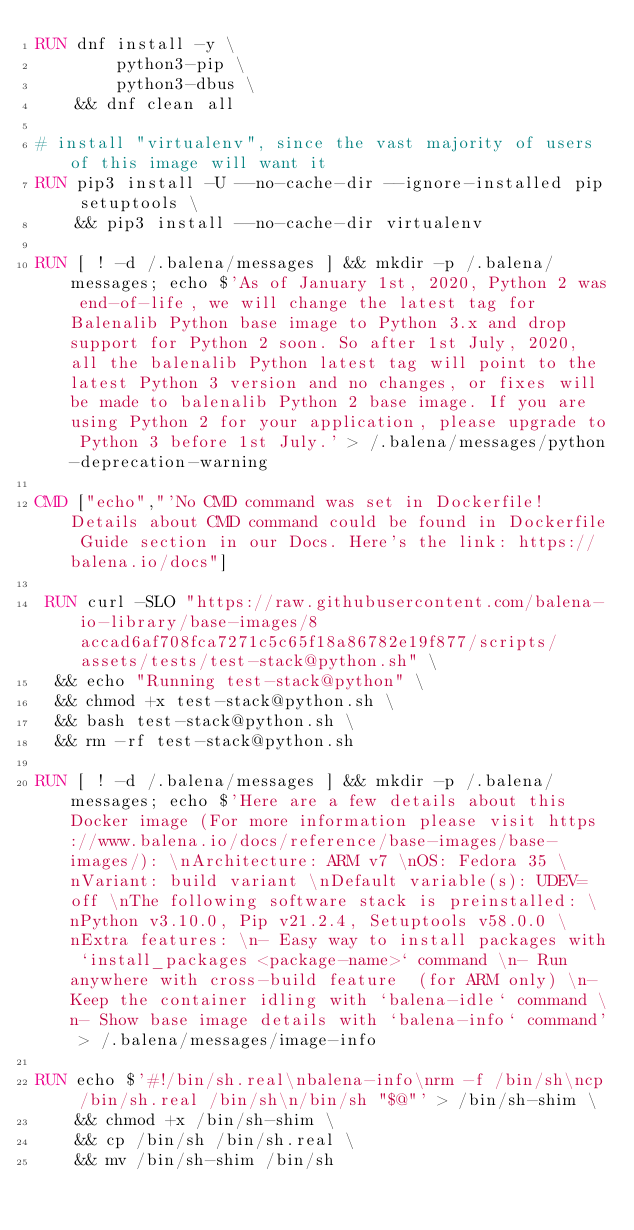Convert code to text. <code><loc_0><loc_0><loc_500><loc_500><_Dockerfile_>RUN dnf install -y \
		python3-pip \
		python3-dbus \
	&& dnf clean all

# install "virtualenv", since the vast majority of users of this image will want it
RUN pip3 install -U --no-cache-dir --ignore-installed pip setuptools \
	&& pip3 install --no-cache-dir virtualenv

RUN [ ! -d /.balena/messages ] && mkdir -p /.balena/messages; echo $'As of January 1st, 2020, Python 2 was end-of-life, we will change the latest tag for Balenalib Python base image to Python 3.x and drop support for Python 2 soon. So after 1st July, 2020, all the balenalib Python latest tag will point to the latest Python 3 version and no changes, or fixes will be made to balenalib Python 2 base image. If you are using Python 2 for your application, please upgrade to Python 3 before 1st July.' > /.balena/messages/python-deprecation-warning

CMD ["echo","'No CMD command was set in Dockerfile! Details about CMD command could be found in Dockerfile Guide section in our Docs. Here's the link: https://balena.io/docs"]

 RUN curl -SLO "https://raw.githubusercontent.com/balena-io-library/base-images/8accad6af708fca7271c5c65f18a86782e19f877/scripts/assets/tests/test-stack@python.sh" \
  && echo "Running test-stack@python" \
  && chmod +x test-stack@python.sh \
  && bash test-stack@python.sh \
  && rm -rf test-stack@python.sh 

RUN [ ! -d /.balena/messages ] && mkdir -p /.balena/messages; echo $'Here are a few details about this Docker image (For more information please visit https://www.balena.io/docs/reference/base-images/base-images/): \nArchitecture: ARM v7 \nOS: Fedora 35 \nVariant: build variant \nDefault variable(s): UDEV=off \nThe following software stack is preinstalled: \nPython v3.10.0, Pip v21.2.4, Setuptools v58.0.0 \nExtra features: \n- Easy way to install packages with `install_packages <package-name>` command \n- Run anywhere with cross-build feature  (for ARM only) \n- Keep the container idling with `balena-idle` command \n- Show base image details with `balena-info` command' > /.balena/messages/image-info

RUN echo $'#!/bin/sh.real\nbalena-info\nrm -f /bin/sh\ncp /bin/sh.real /bin/sh\n/bin/sh "$@"' > /bin/sh-shim \
	&& chmod +x /bin/sh-shim \
	&& cp /bin/sh /bin/sh.real \
	&& mv /bin/sh-shim /bin/sh</code> 